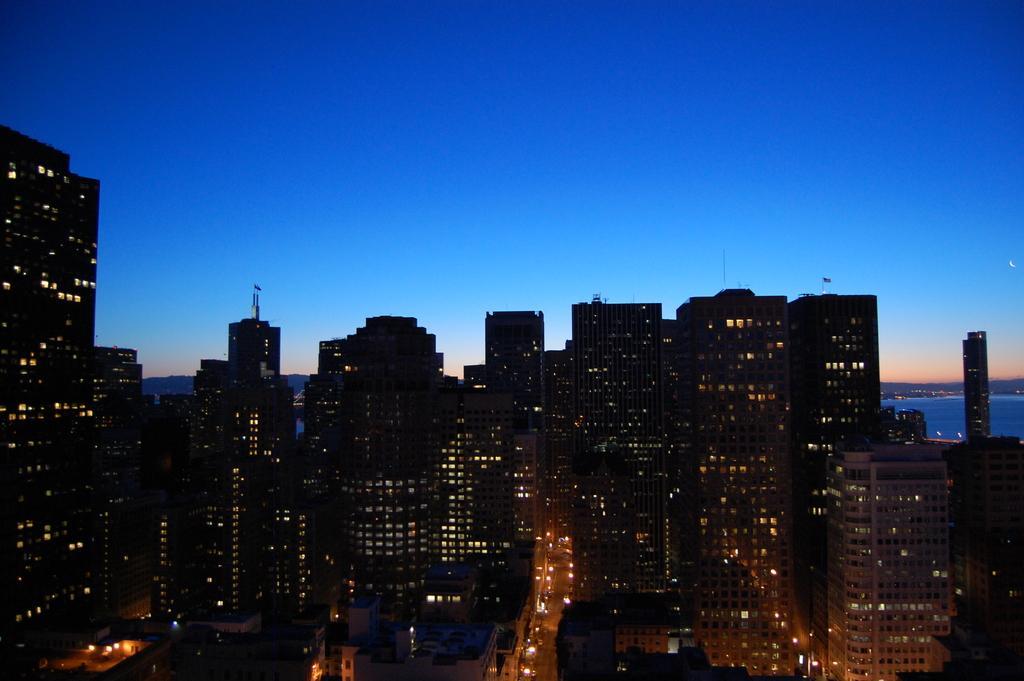Please provide a concise description of this image. In this image, I can see the view of the city. These are the buildings with the lights. I can see a road with the vehicles. Here is the sky. On the right side of the image, I can see the water. 